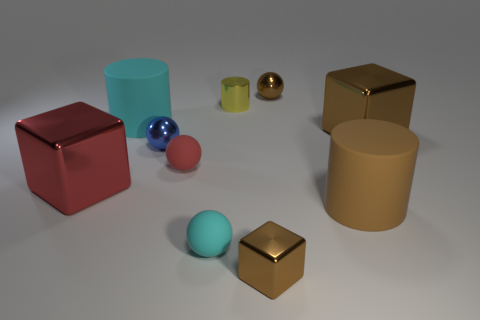Subtract all brown balls. How many brown cubes are left? 2 Subtract all big metallic cubes. How many cubes are left? 1 Subtract 1 cylinders. How many cylinders are left? 2 Subtract all blue balls. How many balls are left? 3 Subtract all green balls. Subtract all red cylinders. How many balls are left? 4 Subtract 1 brown cylinders. How many objects are left? 9 Subtract all cylinders. How many objects are left? 7 Subtract all brown cylinders. Subtract all big gray cubes. How many objects are left? 9 Add 6 big metal things. How many big metal things are left? 8 Add 3 big shiny blocks. How many big shiny blocks exist? 5 